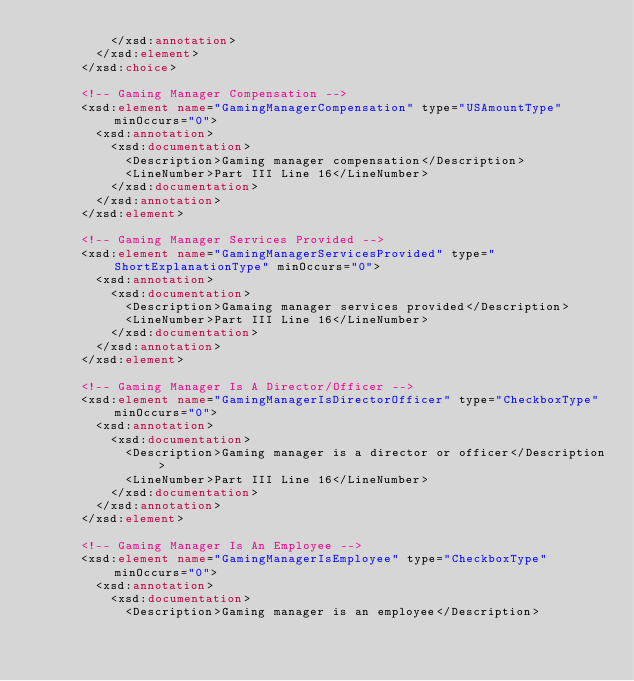<code> <loc_0><loc_0><loc_500><loc_500><_XML_>					</xsd:annotation>
				</xsd:element>
			</xsd:choice>

			<!-- Gaming Manager Compensation -->
			<xsd:element name="GamingManagerCompensation" type="USAmountType" minOccurs="0">
				<xsd:annotation>
					<xsd:documentation>
						<Description>Gaming manager compensation</Description>
						<LineNumber>Part III Line 16</LineNumber>
					</xsd:documentation>
				</xsd:annotation>
			</xsd:element>

			<!-- Gaming Manager Services Provided -->
			<xsd:element name="GamingManagerServicesProvided" type="ShortExplanationType" minOccurs="0">
				<xsd:annotation>
					<xsd:documentation>
						<Description>Gamaing manager services provided</Description>
						<LineNumber>Part III Line 16</LineNumber>
					</xsd:documentation>
				</xsd:annotation>
			</xsd:element>

			<!-- Gaming Manager Is A Director/Officer -->
			<xsd:element name="GamingManagerIsDirectorOfficer" type="CheckboxType" minOccurs="0">
				<xsd:annotation>
					<xsd:documentation>
						<Description>Gaming manager is a director or officer</Description>
						<LineNumber>Part III Line 16</LineNumber>
					</xsd:documentation>
				</xsd:annotation>
			</xsd:element>

			<!-- Gaming Manager Is An Employee -->
			<xsd:element name="GamingManagerIsEmployee" type="CheckboxType" minOccurs="0">
				<xsd:annotation>
					<xsd:documentation>
						<Description>Gaming manager is an employee</Description></code> 